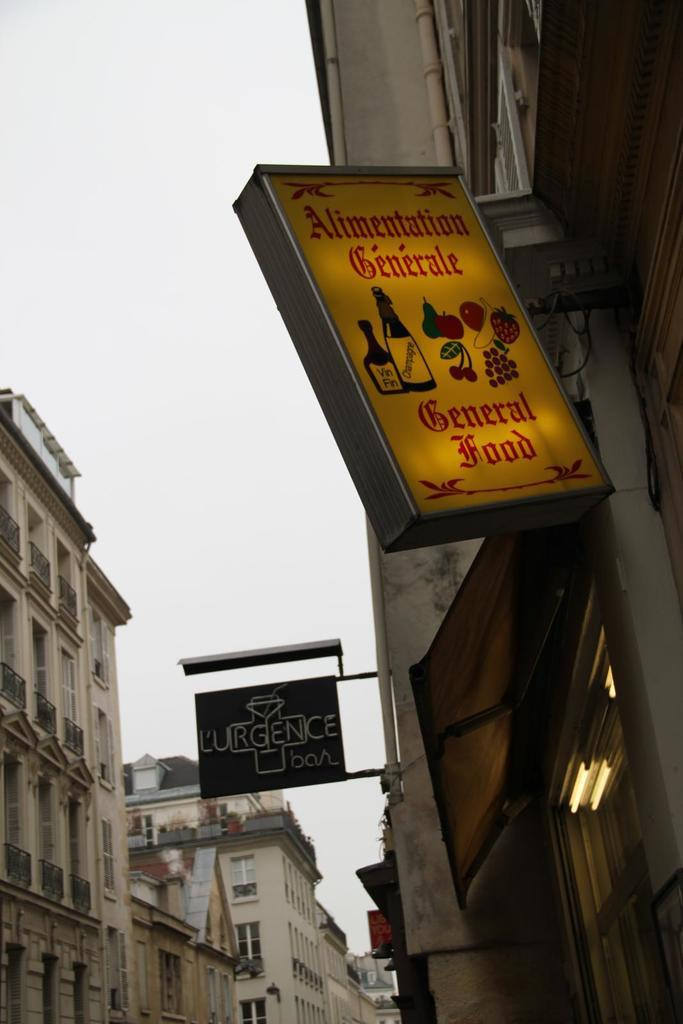<image>
Write a terse but informative summary of the picture. A downtown with a sign reading general food 